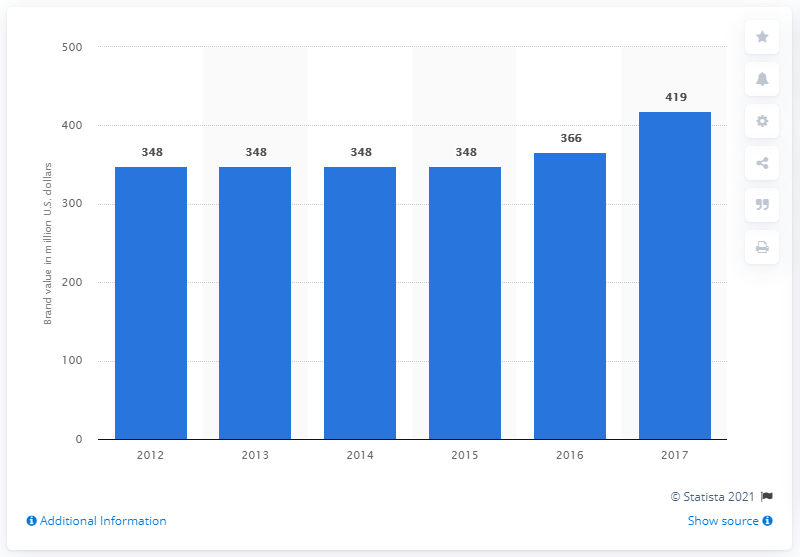Draw attention to some important aspects in this diagram. The brand value of the Summer Olympic Games in 2017 was estimated to be 419. 